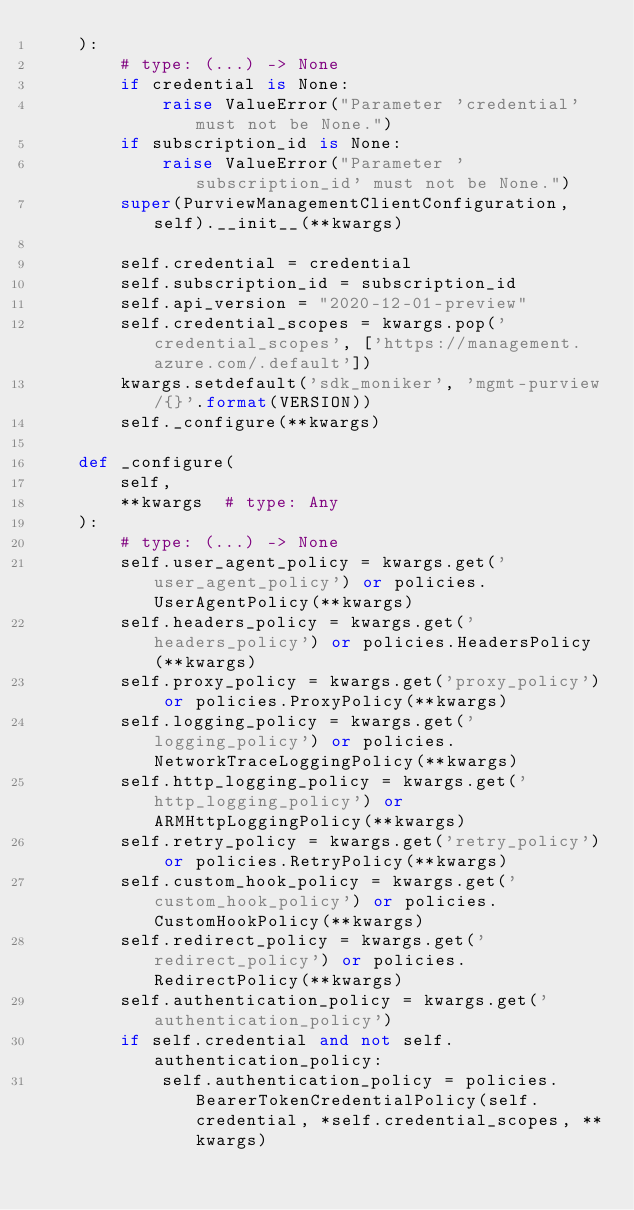<code> <loc_0><loc_0><loc_500><loc_500><_Python_>    ):
        # type: (...) -> None
        if credential is None:
            raise ValueError("Parameter 'credential' must not be None.")
        if subscription_id is None:
            raise ValueError("Parameter 'subscription_id' must not be None.")
        super(PurviewManagementClientConfiguration, self).__init__(**kwargs)

        self.credential = credential
        self.subscription_id = subscription_id
        self.api_version = "2020-12-01-preview"
        self.credential_scopes = kwargs.pop('credential_scopes', ['https://management.azure.com/.default'])
        kwargs.setdefault('sdk_moniker', 'mgmt-purview/{}'.format(VERSION))
        self._configure(**kwargs)

    def _configure(
        self,
        **kwargs  # type: Any
    ):
        # type: (...) -> None
        self.user_agent_policy = kwargs.get('user_agent_policy') or policies.UserAgentPolicy(**kwargs)
        self.headers_policy = kwargs.get('headers_policy') or policies.HeadersPolicy(**kwargs)
        self.proxy_policy = kwargs.get('proxy_policy') or policies.ProxyPolicy(**kwargs)
        self.logging_policy = kwargs.get('logging_policy') or policies.NetworkTraceLoggingPolicy(**kwargs)
        self.http_logging_policy = kwargs.get('http_logging_policy') or ARMHttpLoggingPolicy(**kwargs)
        self.retry_policy = kwargs.get('retry_policy') or policies.RetryPolicy(**kwargs)
        self.custom_hook_policy = kwargs.get('custom_hook_policy') or policies.CustomHookPolicy(**kwargs)
        self.redirect_policy = kwargs.get('redirect_policy') or policies.RedirectPolicy(**kwargs)
        self.authentication_policy = kwargs.get('authentication_policy')
        if self.credential and not self.authentication_policy:
            self.authentication_policy = policies.BearerTokenCredentialPolicy(self.credential, *self.credential_scopes, **kwargs)
</code> 